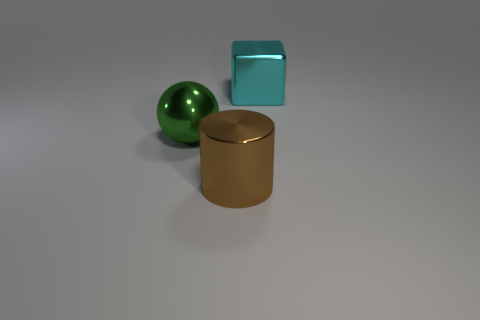Add 2 cyan shiny objects. How many objects exist? 5 Subtract all cubes. How many objects are left? 2 Add 3 tiny green matte cylinders. How many tiny green matte cylinders exist? 3 Subtract 0 red cylinders. How many objects are left? 3 Subtract all blue spheres. Subtract all green cubes. How many spheres are left? 1 Subtract all large cylinders. Subtract all big brown metal cylinders. How many objects are left? 1 Add 1 green metallic balls. How many green metallic balls are left? 2 